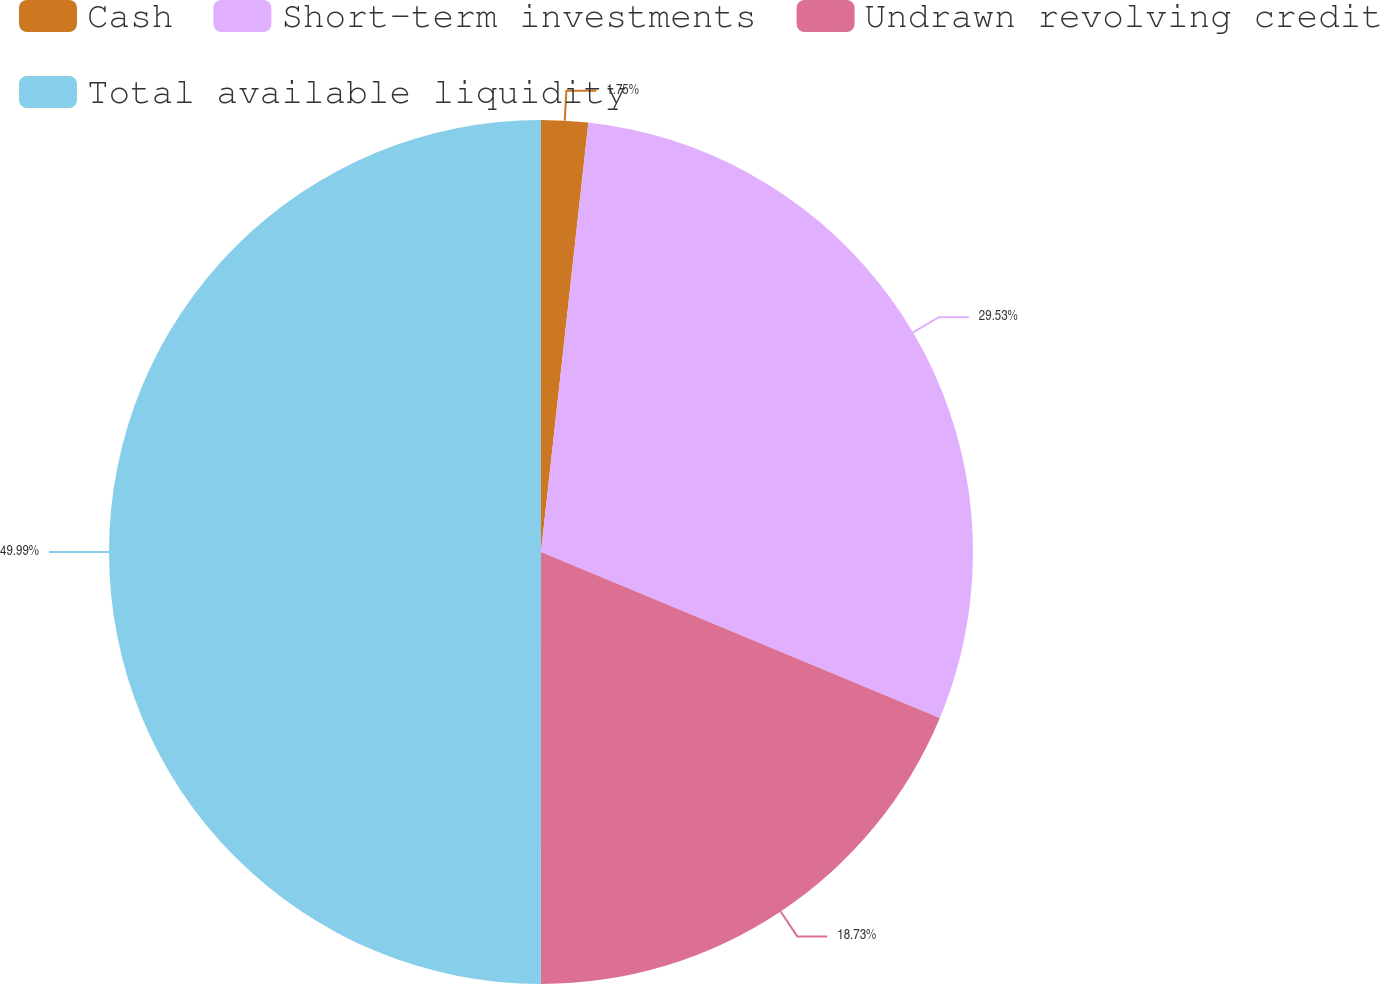Convert chart to OTSL. <chart><loc_0><loc_0><loc_500><loc_500><pie_chart><fcel>Cash<fcel>Short-term investments<fcel>Undrawn revolving credit<fcel>Total available liquidity<nl><fcel>1.75%<fcel>29.53%<fcel>18.73%<fcel>50.0%<nl></chart> 